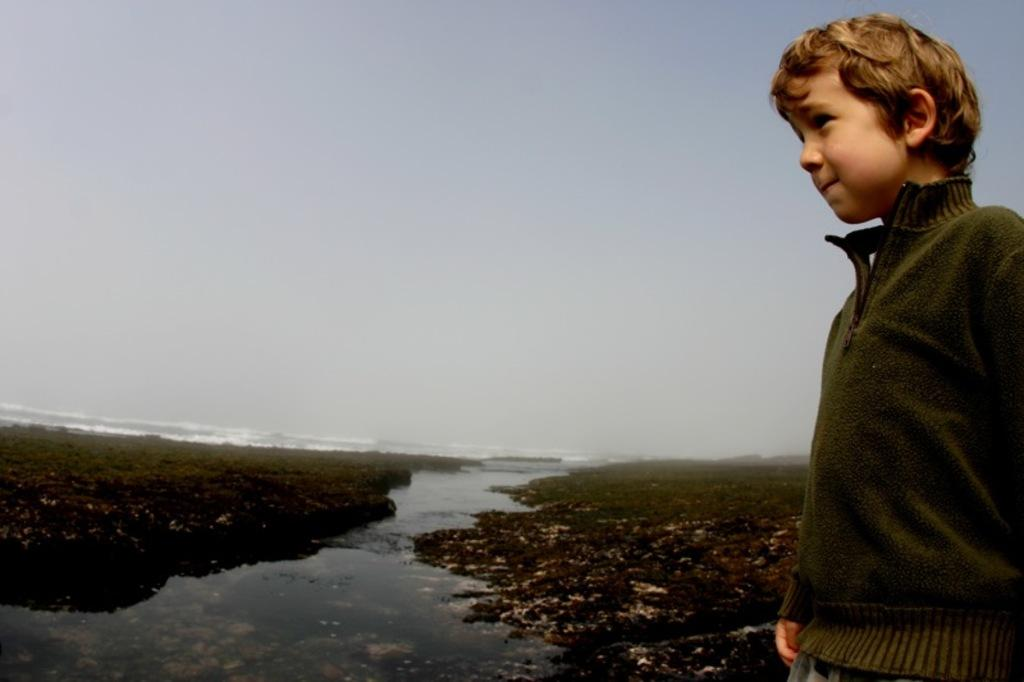What is located on the right side of the image? There is a boy on the right side of the image. What is the boy wearing? The boy is wearing a green sweater. What can be seen in the middle of the image? There is water in the middle of the image. What is visible at the top of the image? The sky is visible at the top of the image. Can you hear the boy whipping something in the image? There is no indication of sound in the image, and the boy is not shown whipping anything. What type of branch can be seen in the image? There is no branch present in the image. 